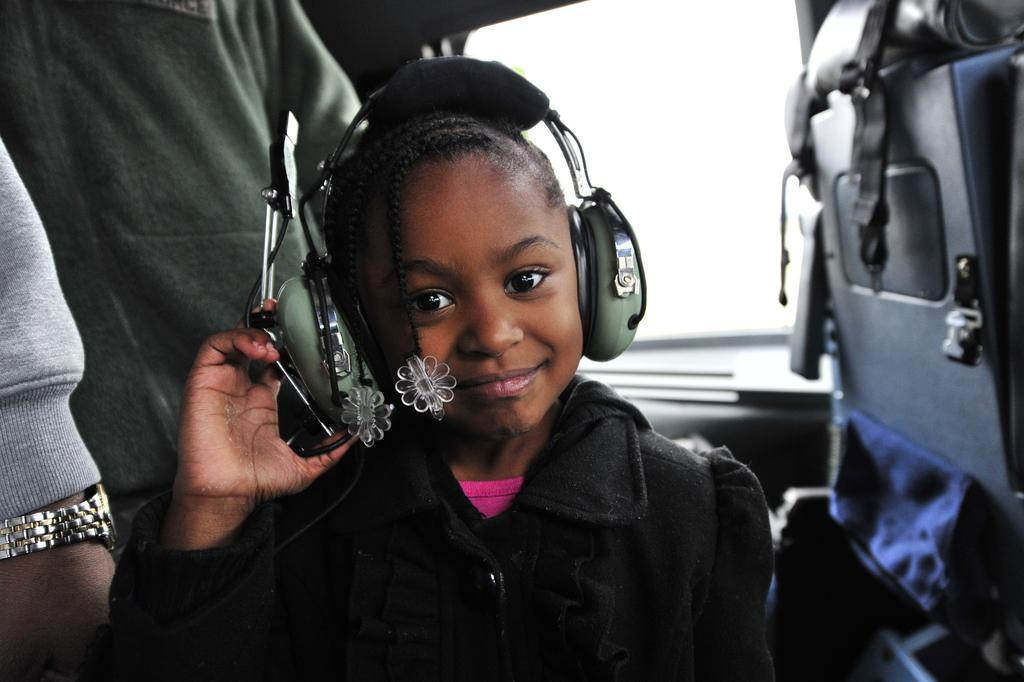What is the person in the image holding? The person is holding a headphone in the image. What can be seen on the right side of the image? There is an object that looks like a vehicle seat on the right side of the image. What is happening with the persons on the left side of the image? The persons on the left side of the image are truncated, meaning they are partially cut off or not fully visible. How does the person in the image express their feeling of thrill while holding the headphone? There is no indication of the person's feelings or emotions in the image, nor is there any evidence of a thrilling experience. 